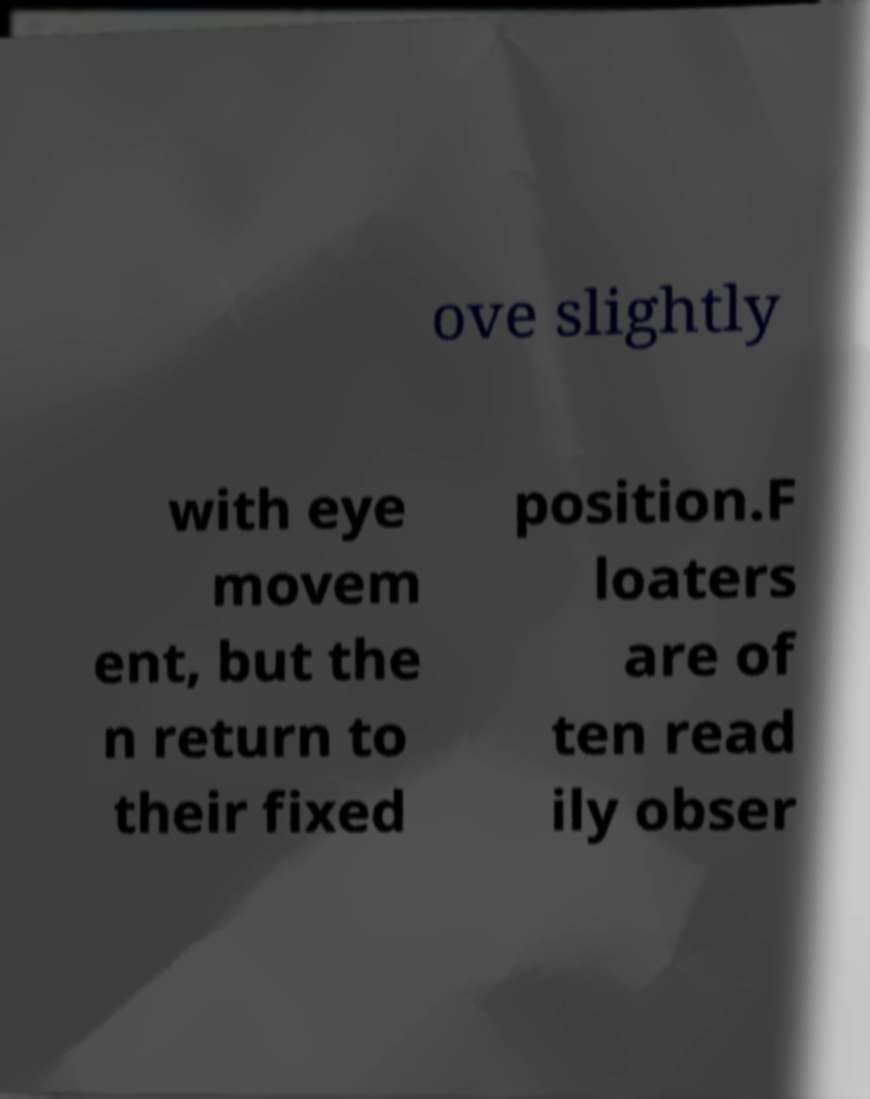There's text embedded in this image that I need extracted. Can you transcribe it verbatim? ove slightly with eye movem ent, but the n return to their fixed position.F loaters are of ten read ily obser 